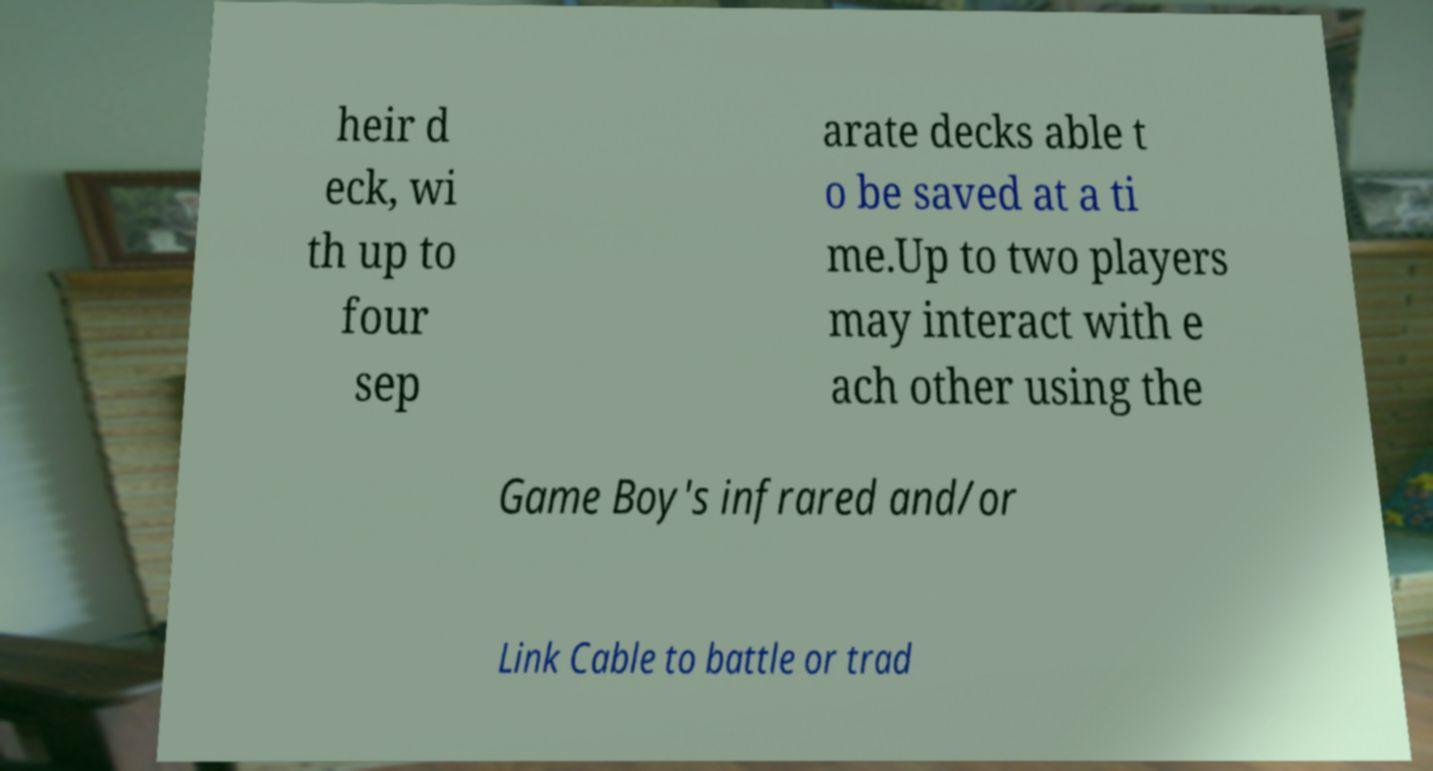I need the written content from this picture converted into text. Can you do that? heir d eck, wi th up to four sep arate decks able t o be saved at a ti me.Up to two players may interact with e ach other using the Game Boy's infrared and/or Link Cable to battle or trad 